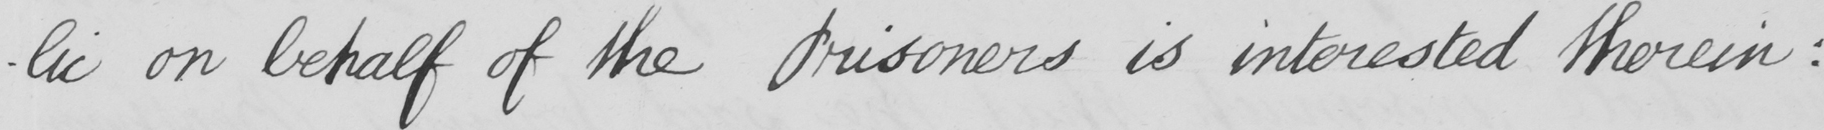Can you tell me what this handwritten text says? -lic  on behalf of the Prisoners is interested therein  : 